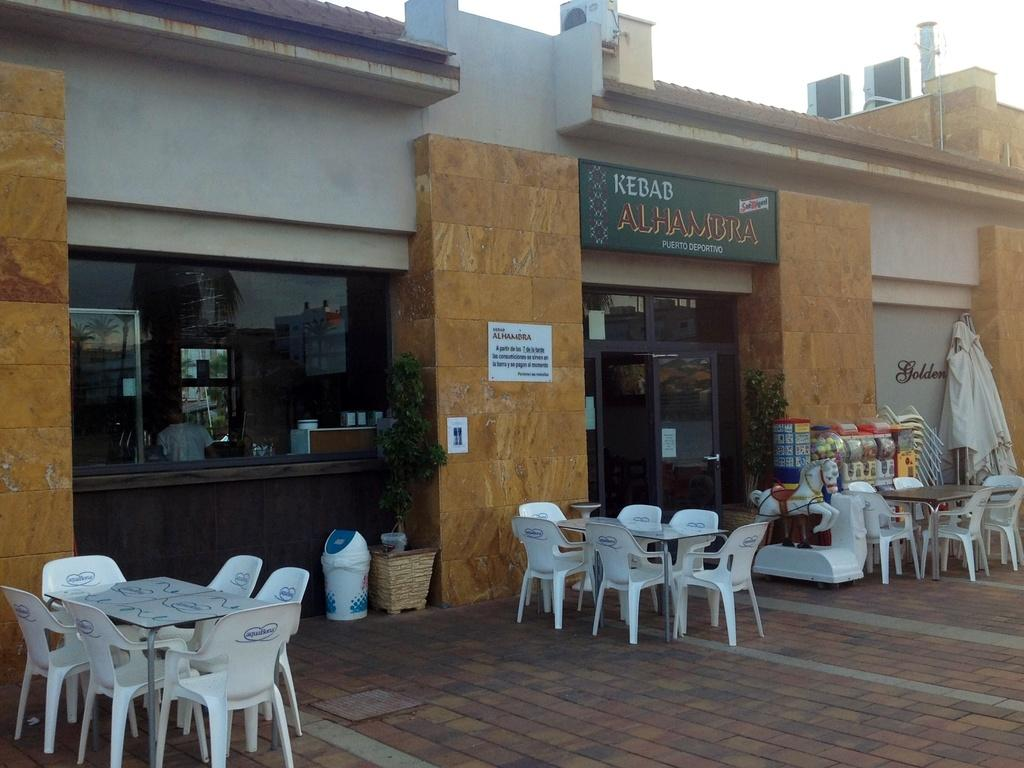What type of establishment is shown in the image? There is a store in the image. How can people enter or exit the store? The store has a door. What furniture is present inside the store? There are tables and chairs in the image. Are there any customers or employees inside the store? Yes, there are people inside the store. What type of food is the store associated with? The store has the word "Kebab" written on it, indicating that it serves kebabs. Where is the grandmother sitting with her pencil in the image? There is no grandmother or pencil present in the image. What type of cooking appliance can be seen in the image? There is no cooking appliance, such as an oven, present in the image. 